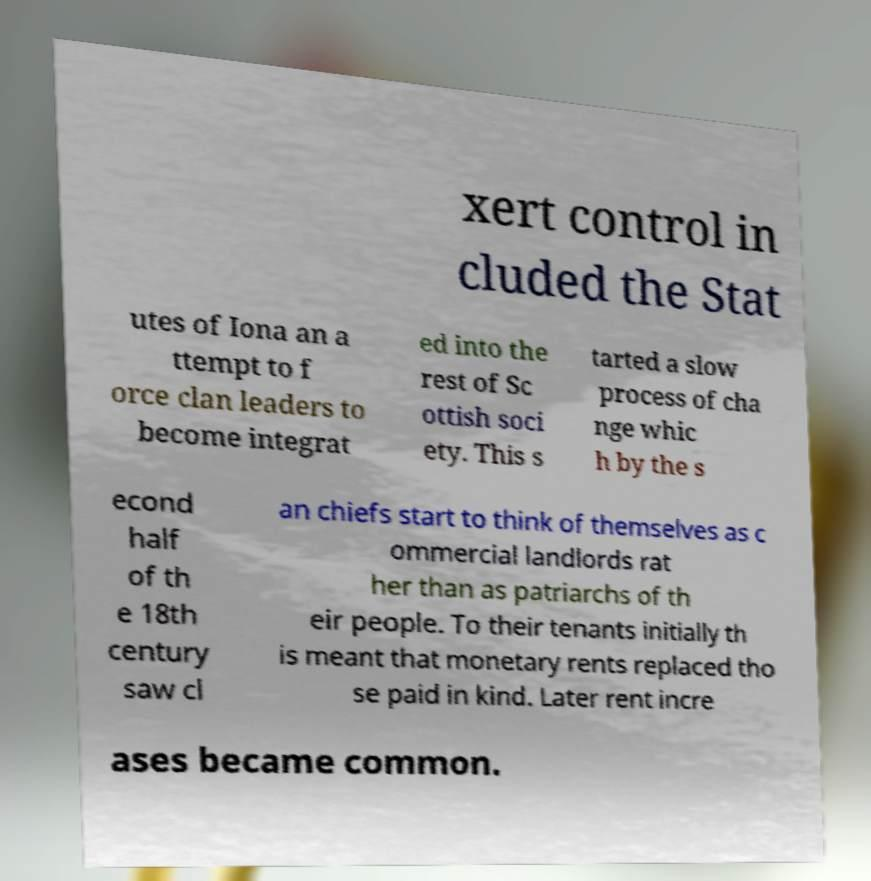For documentation purposes, I need the text within this image transcribed. Could you provide that? xert control in cluded the Stat utes of Iona an a ttempt to f orce clan leaders to become integrat ed into the rest of Sc ottish soci ety. This s tarted a slow process of cha nge whic h by the s econd half of th e 18th century saw cl an chiefs start to think of themselves as c ommercial landlords rat her than as patriarchs of th eir people. To their tenants initially th is meant that monetary rents replaced tho se paid in kind. Later rent incre ases became common. 